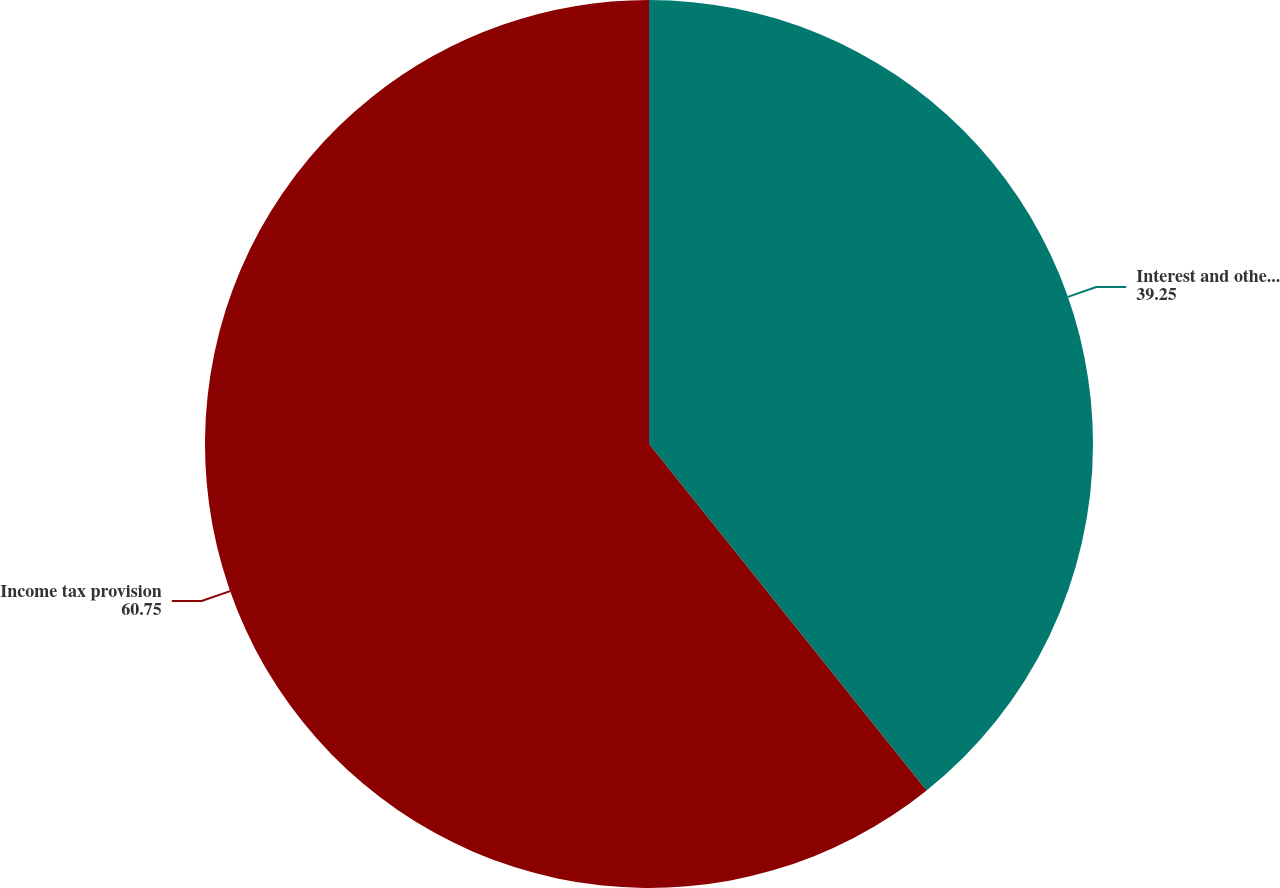Convert chart. <chart><loc_0><loc_0><loc_500><loc_500><pie_chart><fcel>Interest and other income net<fcel>Income tax provision<nl><fcel>39.25%<fcel>60.75%<nl></chart> 